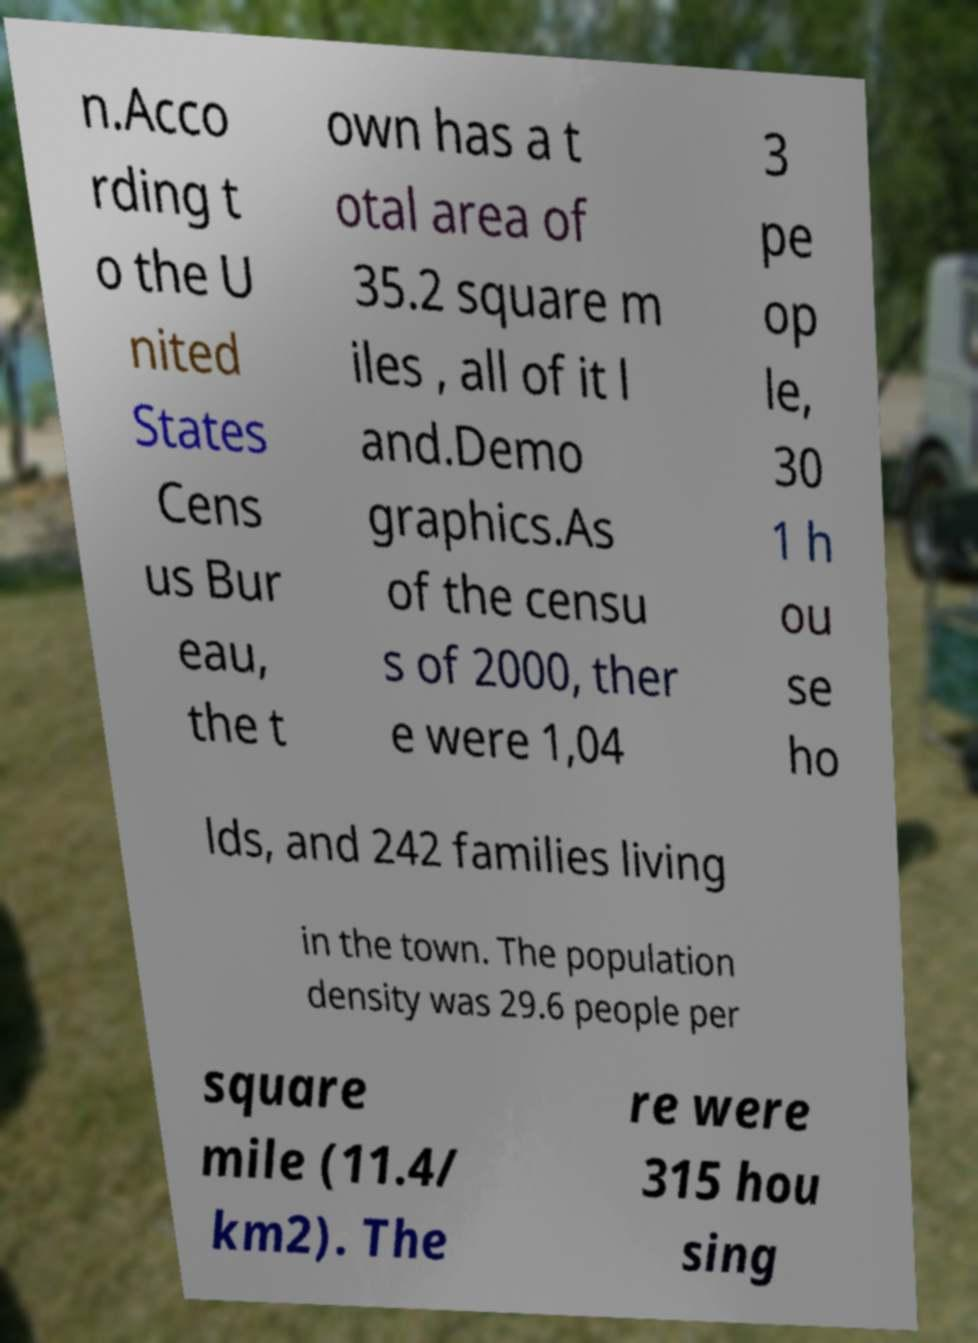Could you extract and type out the text from this image? n.Acco rding t o the U nited States Cens us Bur eau, the t own has a t otal area of 35.2 square m iles , all of it l and.Demo graphics.As of the censu s of 2000, ther e were 1,04 3 pe op le, 30 1 h ou se ho lds, and 242 families living in the town. The population density was 29.6 people per square mile (11.4/ km2). The re were 315 hou sing 